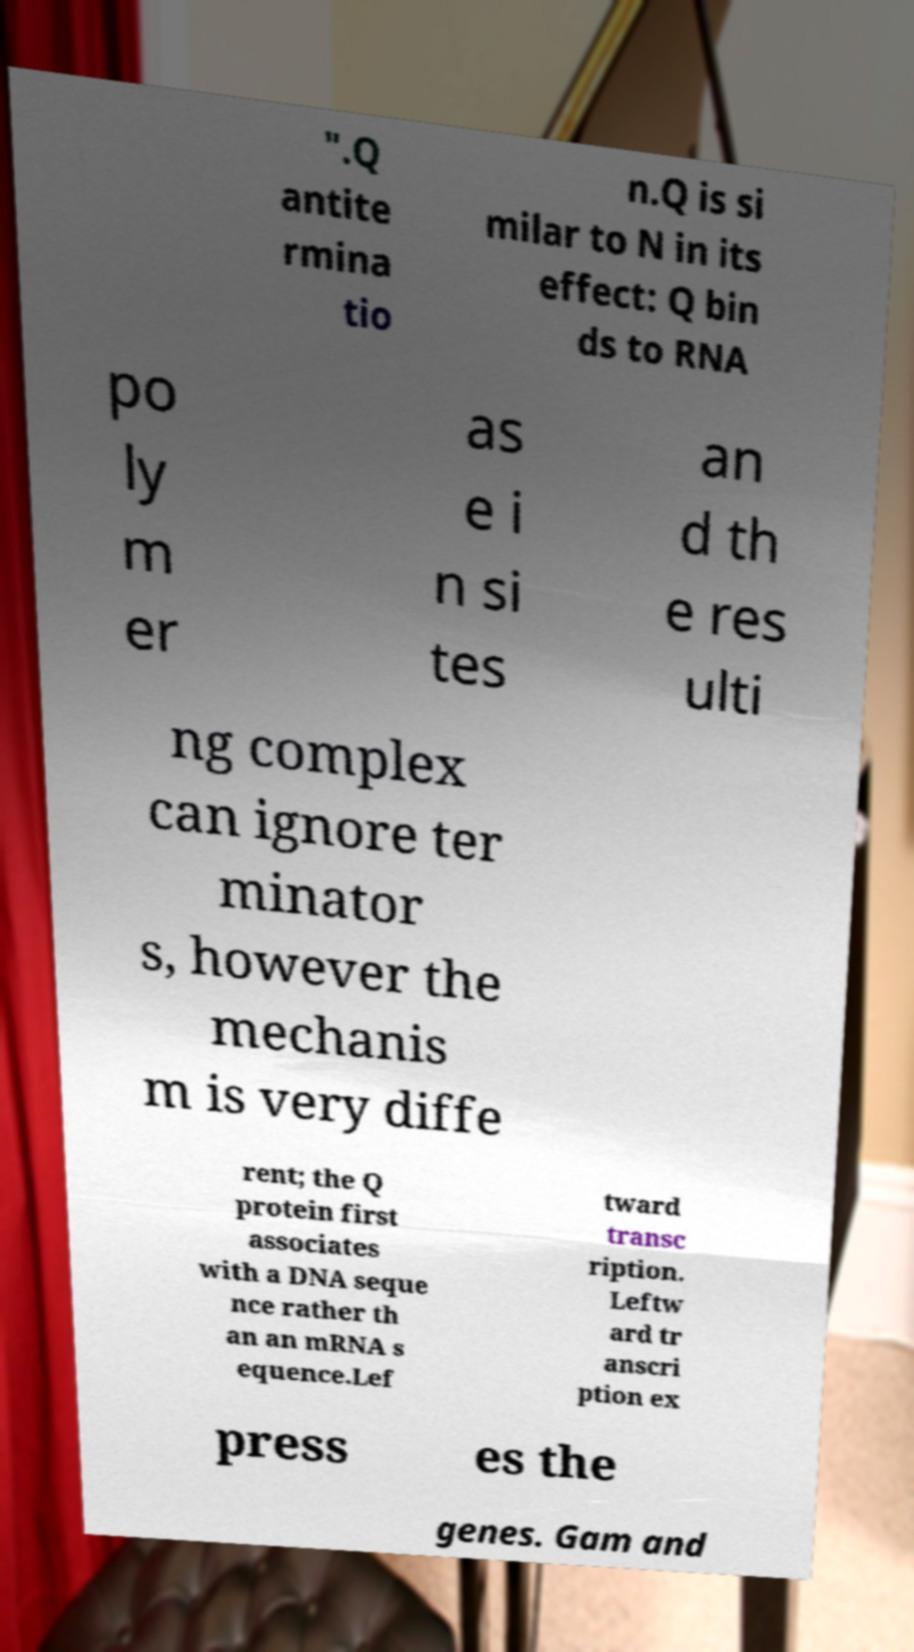Please identify and transcribe the text found in this image. ".Q antite rmina tio n.Q is si milar to N in its effect: Q bin ds to RNA po ly m er as e i n si tes an d th e res ulti ng complex can ignore ter minator s, however the mechanis m is very diffe rent; the Q protein first associates with a DNA seque nce rather th an an mRNA s equence.Lef tward transc ription. Leftw ard tr anscri ption ex press es the genes. Gam and 